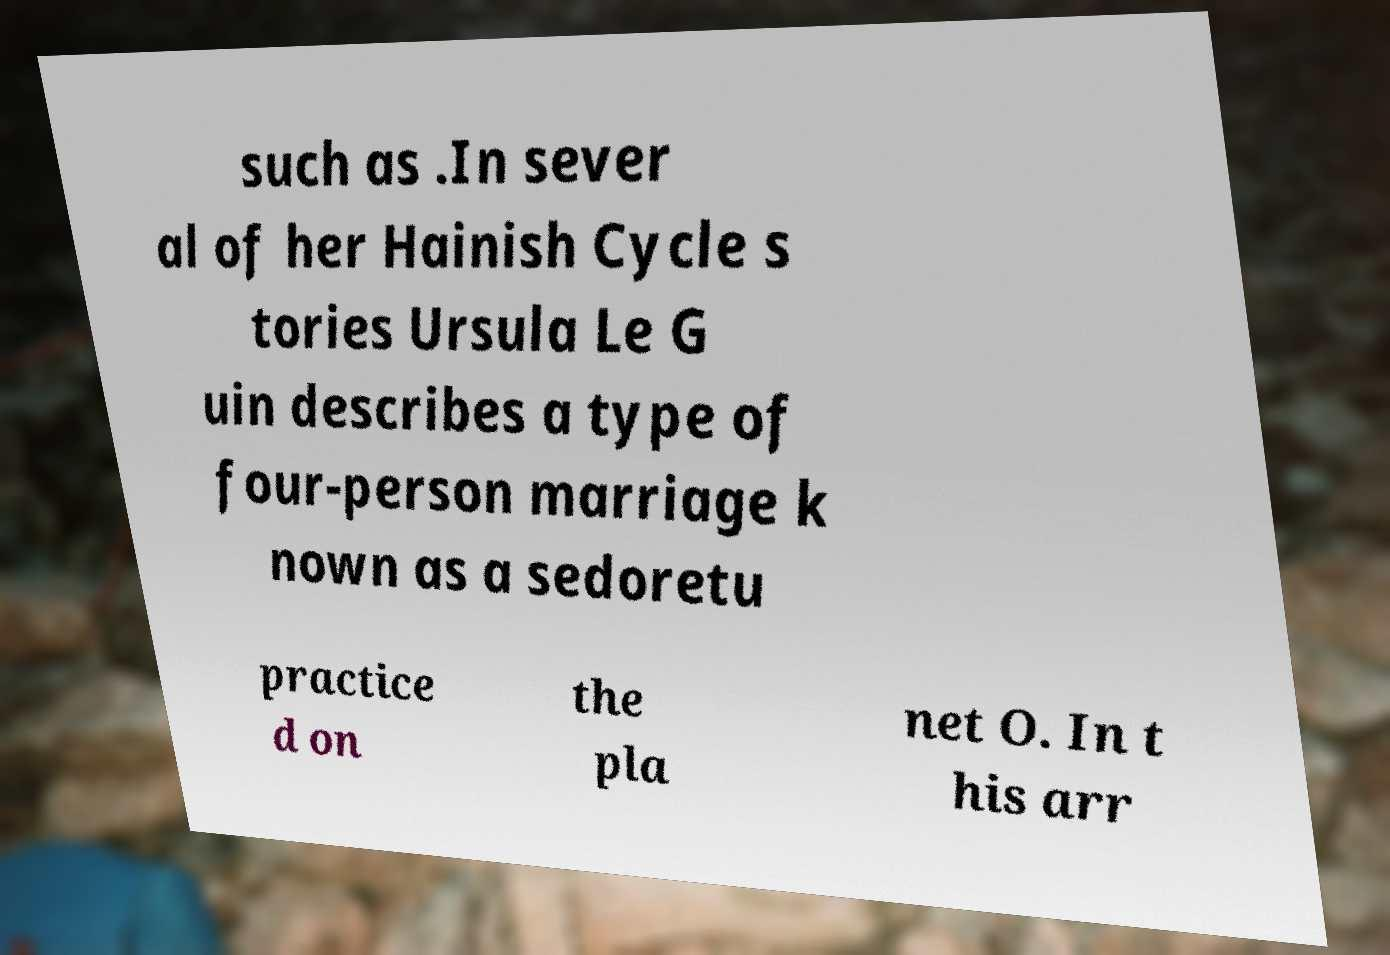Can you read and provide the text displayed in the image?This photo seems to have some interesting text. Can you extract and type it out for me? such as .In sever al of her Hainish Cycle s tories Ursula Le G uin describes a type of four-person marriage k nown as a sedoretu practice d on the pla net O. In t his arr 